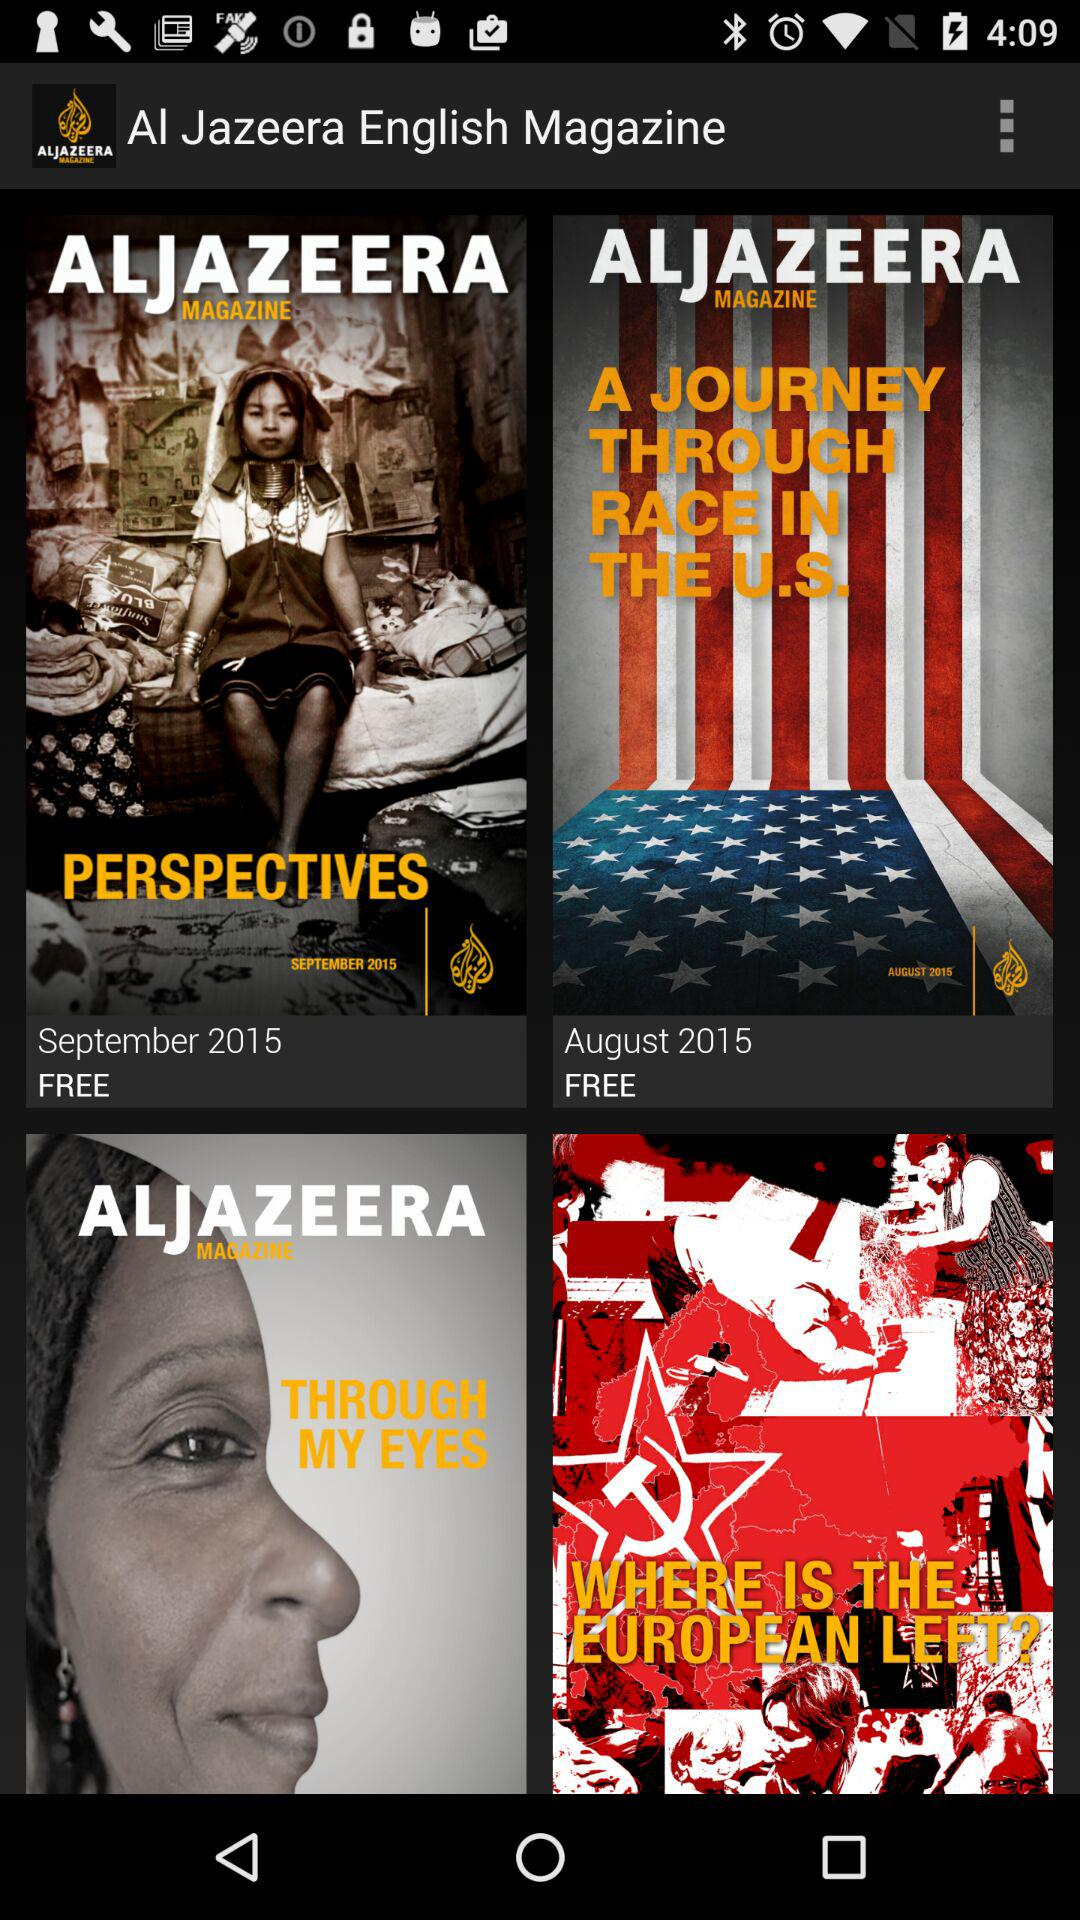What is the masthead of the September 2015 issue of the magazine? The masthead of the September 2015 issue of the magazine is "ALJAZEERA MAGAZINE". 